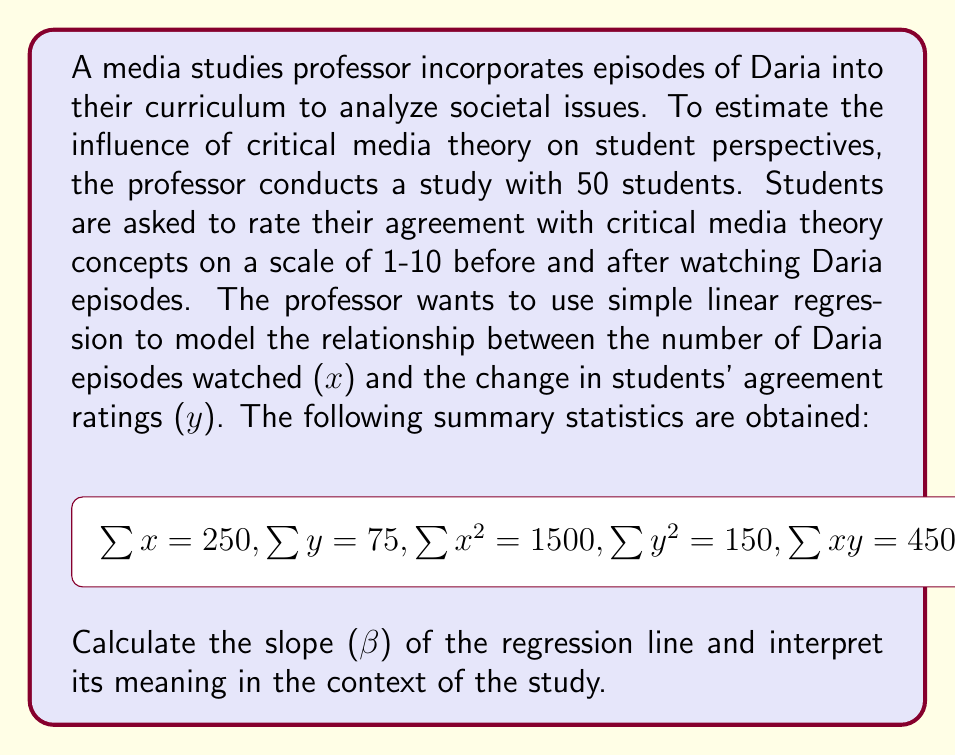Provide a solution to this math problem. To calculate the slope (β) of the regression line, we'll use the formula:

$$\beta = \frac{n\sum xy - \sum x \sum y}{n\sum x^2 - (\sum x)^2}$$

Where n is the number of students (50).

Step 1: Calculate the numerator
$$n\sum xy - \sum x \sum y = 50(450) - 250(75) = 22500 - 18750 = 3750$$

Step 2: Calculate the denominator
$$n\sum x^2 - (\sum x)^2 = 50(1500) - 250^2 = 75000 - 62500 = 12500$$

Step 3: Divide the numerator by the denominator
$$\beta = \frac{3750}{12500} = 0.3$$

Interpretation:
The slope (β) of 0.3 indicates that for each additional Daria episode watched, the average change in students' agreement ratings with critical media theory concepts increases by 0.3 points on the 1-10 scale. This suggests a positive relationship between exposure to Daria episodes and students' alignment with critical media theory perspectives.
Answer: β = 0.3; For each Daria episode watched, students' agreement with critical media theory concepts increases by 0.3 points on average. 